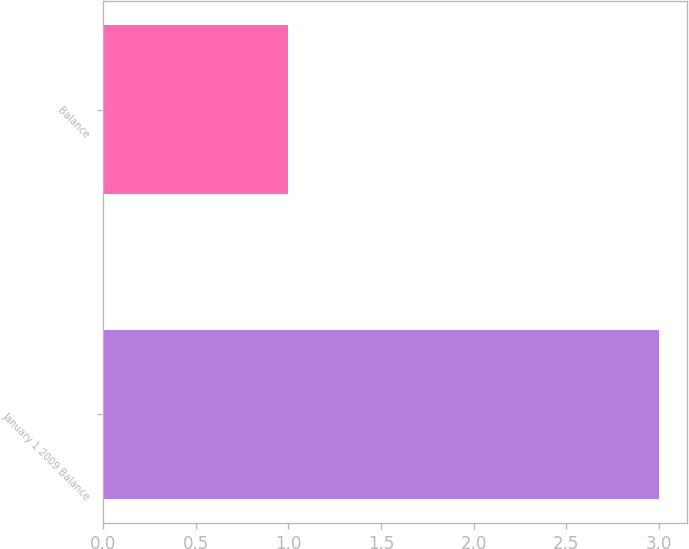<chart> <loc_0><loc_0><loc_500><loc_500><bar_chart><fcel>January 1 2009 Balance<fcel>Balance<nl><fcel>3<fcel>1<nl></chart> 